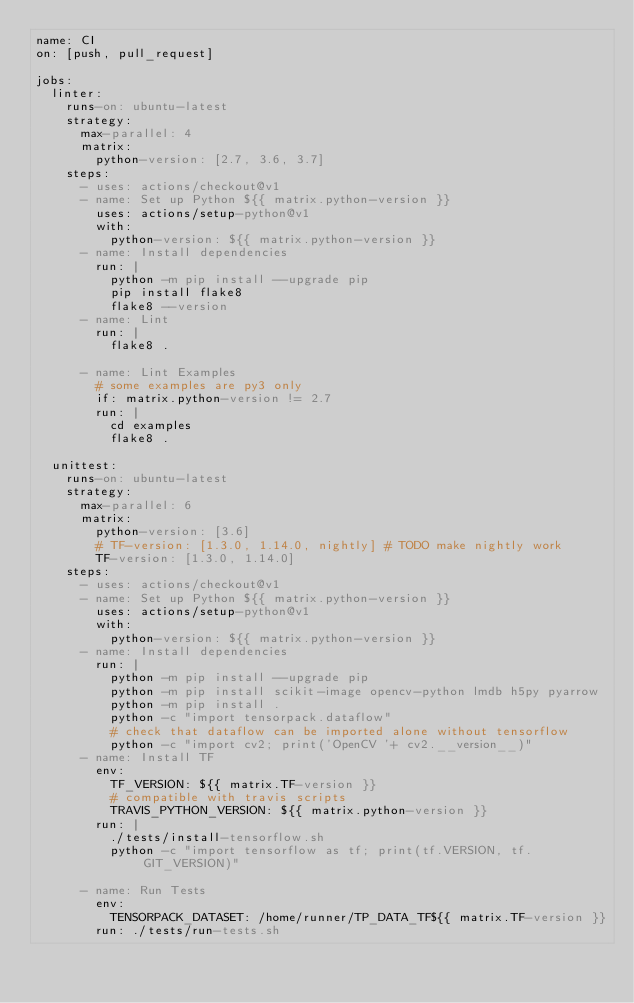Convert code to text. <code><loc_0><loc_0><loc_500><loc_500><_YAML_>name: CI
on: [push, pull_request]

jobs:
  linter:
    runs-on: ubuntu-latest
    strategy:
      max-parallel: 4
      matrix:
        python-version: [2.7, 3.6, 3.7]
    steps:
      - uses: actions/checkout@v1
      - name: Set up Python ${{ matrix.python-version }}
        uses: actions/setup-python@v1
        with:
          python-version: ${{ matrix.python-version }}
      - name: Install dependencies
        run: |
          python -m pip install --upgrade pip
          pip install flake8
          flake8 --version
      - name: Lint
        run: |
          flake8 .

      - name: Lint Examples
        # some examples are py3 only
        if: matrix.python-version != 2.7
        run: |
          cd examples
          flake8 .

  unittest:
    runs-on: ubuntu-latest
    strategy:
      max-parallel: 6
      matrix:
        python-version: [3.6]
        # TF-version: [1.3.0, 1.14.0, nightly] # TODO make nightly work
        TF-version: [1.3.0, 1.14.0]
    steps:
      - uses: actions/checkout@v1
      - name: Set up Python ${{ matrix.python-version }}
        uses: actions/setup-python@v1
        with:
          python-version: ${{ matrix.python-version }}
      - name: Install dependencies
        run: |
          python -m pip install --upgrade pip
          python -m pip install scikit-image opencv-python lmdb h5py pyarrow
          python -m pip install .
          python -c "import tensorpack.dataflow"
          # check that dataflow can be imported alone without tensorflow
          python -c "import cv2; print('OpenCV '+ cv2.__version__)"
      - name: Install TF
        env:
          TF_VERSION: ${{ matrix.TF-version }}
          # compatible with travis scripts
          TRAVIS_PYTHON_VERSION: ${{ matrix.python-version }}
        run: |
          ./tests/install-tensorflow.sh
          python -c "import tensorflow as tf; print(tf.VERSION, tf.GIT_VERSION)"

      - name: Run Tests
        env:
          TENSORPACK_DATASET: /home/runner/TP_DATA_TF${{ matrix.TF-version }}
        run: ./tests/run-tests.sh
</code> 